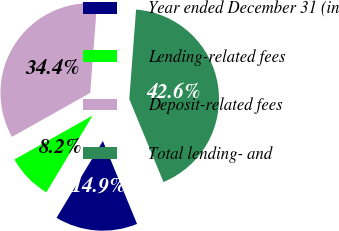Convert chart. <chart><loc_0><loc_0><loc_500><loc_500><pie_chart><fcel>Year ended December 31 (in<fcel>Lending-related fees<fcel>Deposit-related fees<fcel>Total lending- and<nl><fcel>14.86%<fcel>8.21%<fcel>34.36%<fcel>42.57%<nl></chart> 